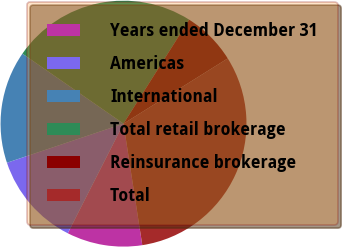Convert chart. <chart><loc_0><loc_0><loc_500><loc_500><pie_chart><fcel>Years ended December 31<fcel>Americas<fcel>International<fcel>Total retail brokerage<fcel>Reinsurance brokerage<fcel>Total<nl><fcel>9.93%<fcel>12.36%<fcel>14.79%<fcel>24.33%<fcel>7.13%<fcel>31.46%<nl></chart> 